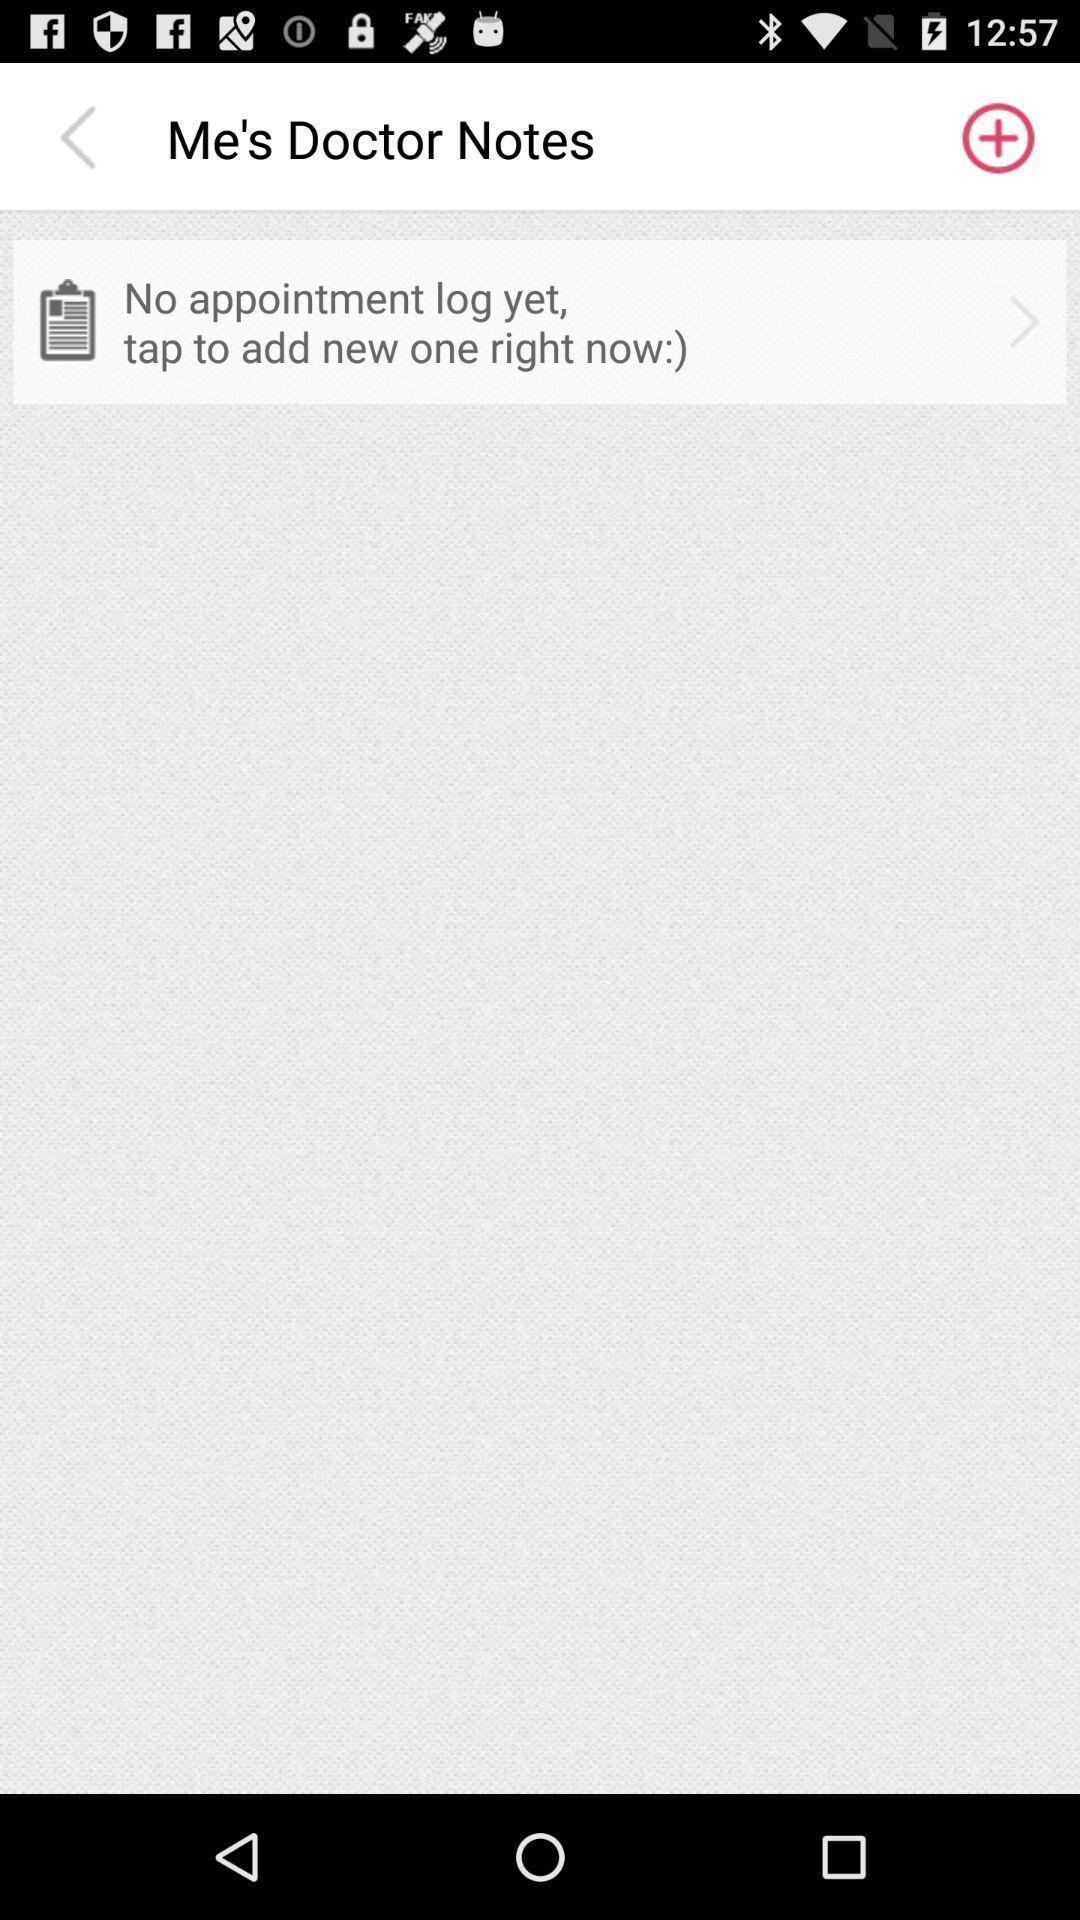Provide a detailed account of this screenshot. Screen shows about doctor notes. 